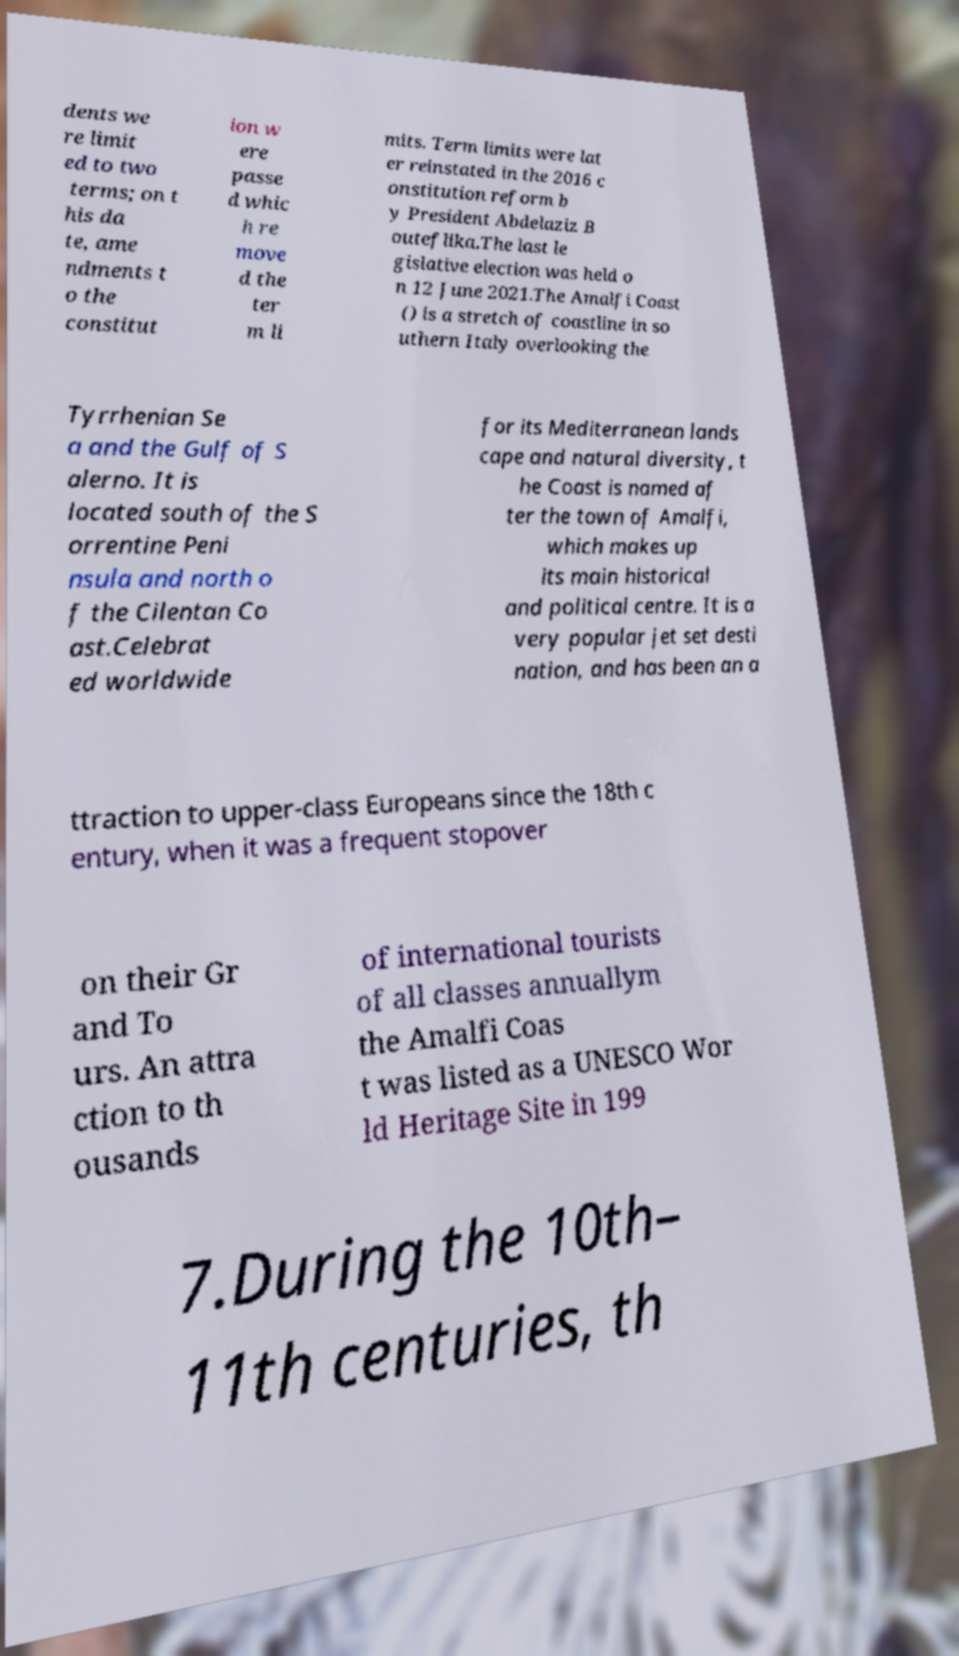For documentation purposes, I need the text within this image transcribed. Could you provide that? dents we re limit ed to two terms; on t his da te, ame ndments t o the constitut ion w ere passe d whic h re move d the ter m li mits. Term limits were lat er reinstated in the 2016 c onstitution reform b y President Abdelaziz B outeflika.The last le gislative election was held o n 12 June 2021.The Amalfi Coast () is a stretch of coastline in so uthern Italy overlooking the Tyrrhenian Se a and the Gulf of S alerno. It is located south of the S orrentine Peni nsula and north o f the Cilentan Co ast.Celebrat ed worldwide for its Mediterranean lands cape and natural diversity, t he Coast is named af ter the town of Amalfi, which makes up its main historical and political centre. It is a very popular jet set desti nation, and has been an a ttraction to upper-class Europeans since the 18th c entury, when it was a frequent stopover on their Gr and To urs. An attra ction to th ousands of international tourists of all classes annuallym the Amalfi Coas t was listed as a UNESCO Wor ld Heritage Site in 199 7.During the 10th– 11th centuries, th 